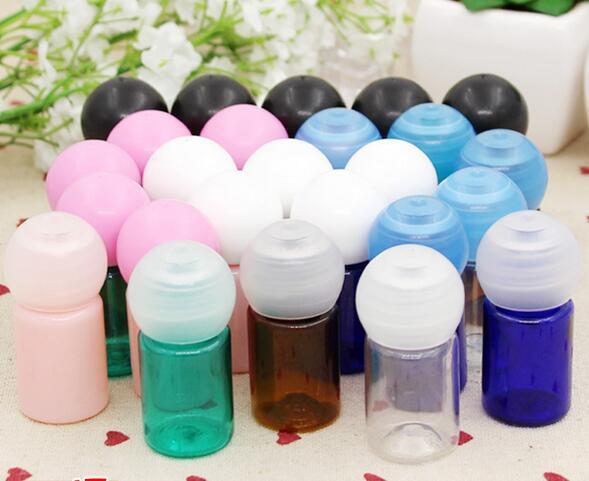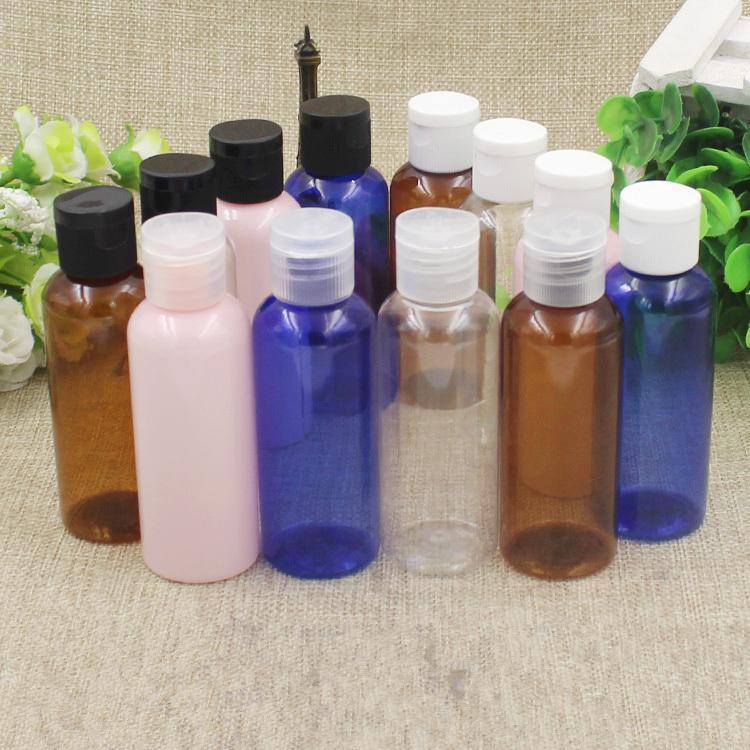The first image is the image on the left, the second image is the image on the right. Given the left and right images, does the statement "The image to the right appears to be all the same brand name lotion, but different scents." hold true? Answer yes or no. No. 